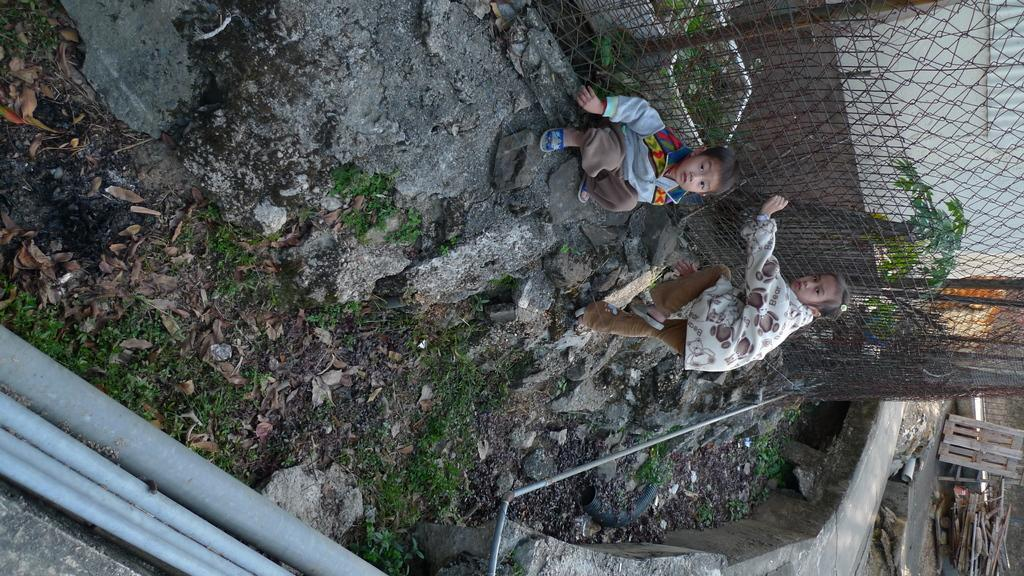How many children are visible in the image? There are two children on the right side of the image. What can be seen in the background of the image? There are woods in the image. What type of structure is present in the image? There is fencing in the image. Where are the pipes located in the image? The pipes are on the left bottom side of the image. What type of hook is hanging from the tree in the image? There is no hook hanging from a tree in the image; it only features two children, fencing, woods, and pipes. 